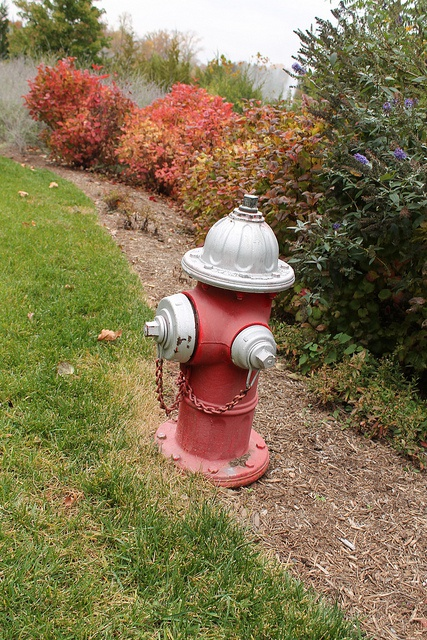Describe the objects in this image and their specific colors. I can see a fire hydrant in white, lightgray, brown, and maroon tones in this image. 